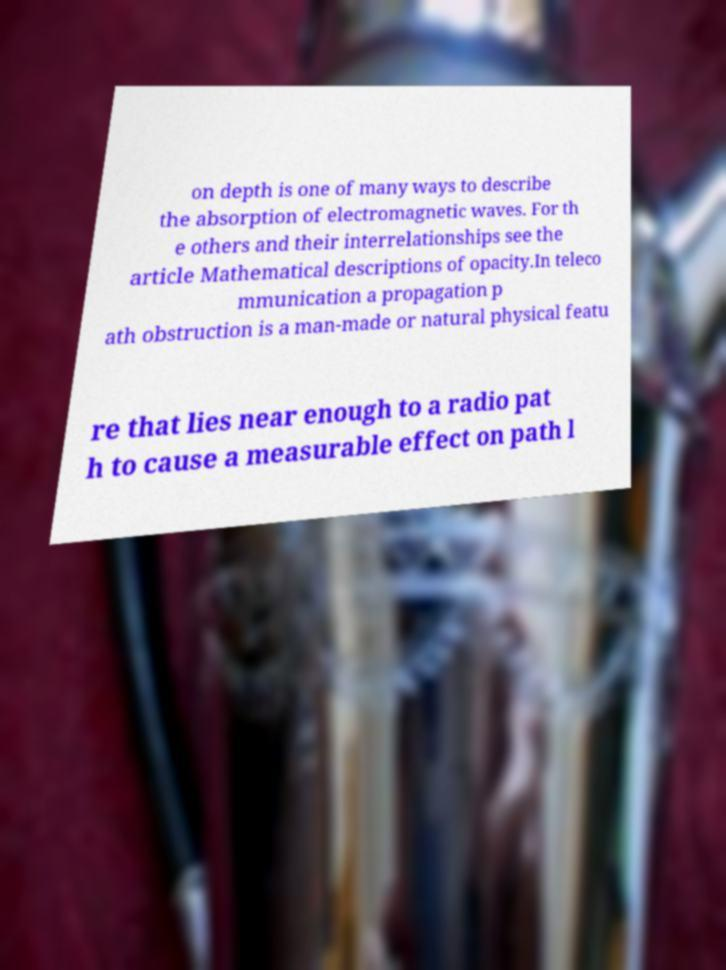For documentation purposes, I need the text within this image transcribed. Could you provide that? on depth is one of many ways to describe the absorption of electromagnetic waves. For th e others and their interrelationships see the article Mathematical descriptions of opacity.In teleco mmunication a propagation p ath obstruction is a man-made or natural physical featu re that lies near enough to a radio pat h to cause a measurable effect on path l 